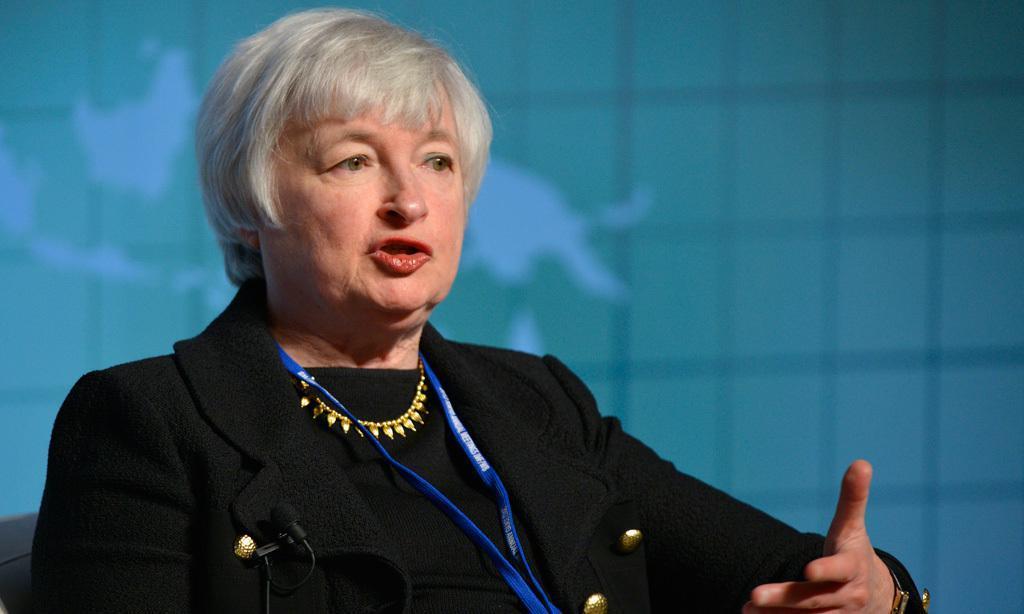Describe this image in one or two sentences. In the image we can see there is a person and she is wearing a jacket and id card. There is a mic kept on the jacket and behind there is a wall. Background of the image is little blurred. 